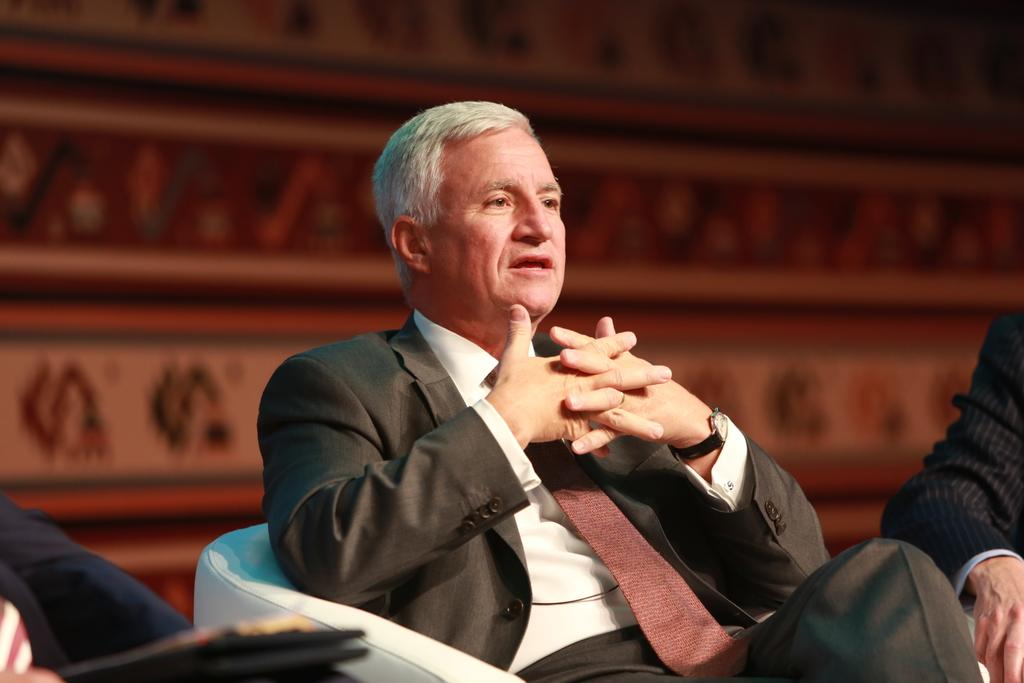Who is present in the image? There is a man in the image. What is the man doing in the image? The man is sitting in a chair. What is the man wearing in the image? The man is wearing a coat and a tie. Can you describe the background of the image? The background of the image is blurred. What type of memory is the man holding in the image? There is no memory present in the image; it is a man sitting in a chair wearing a coat and a tie with a blurred background. 